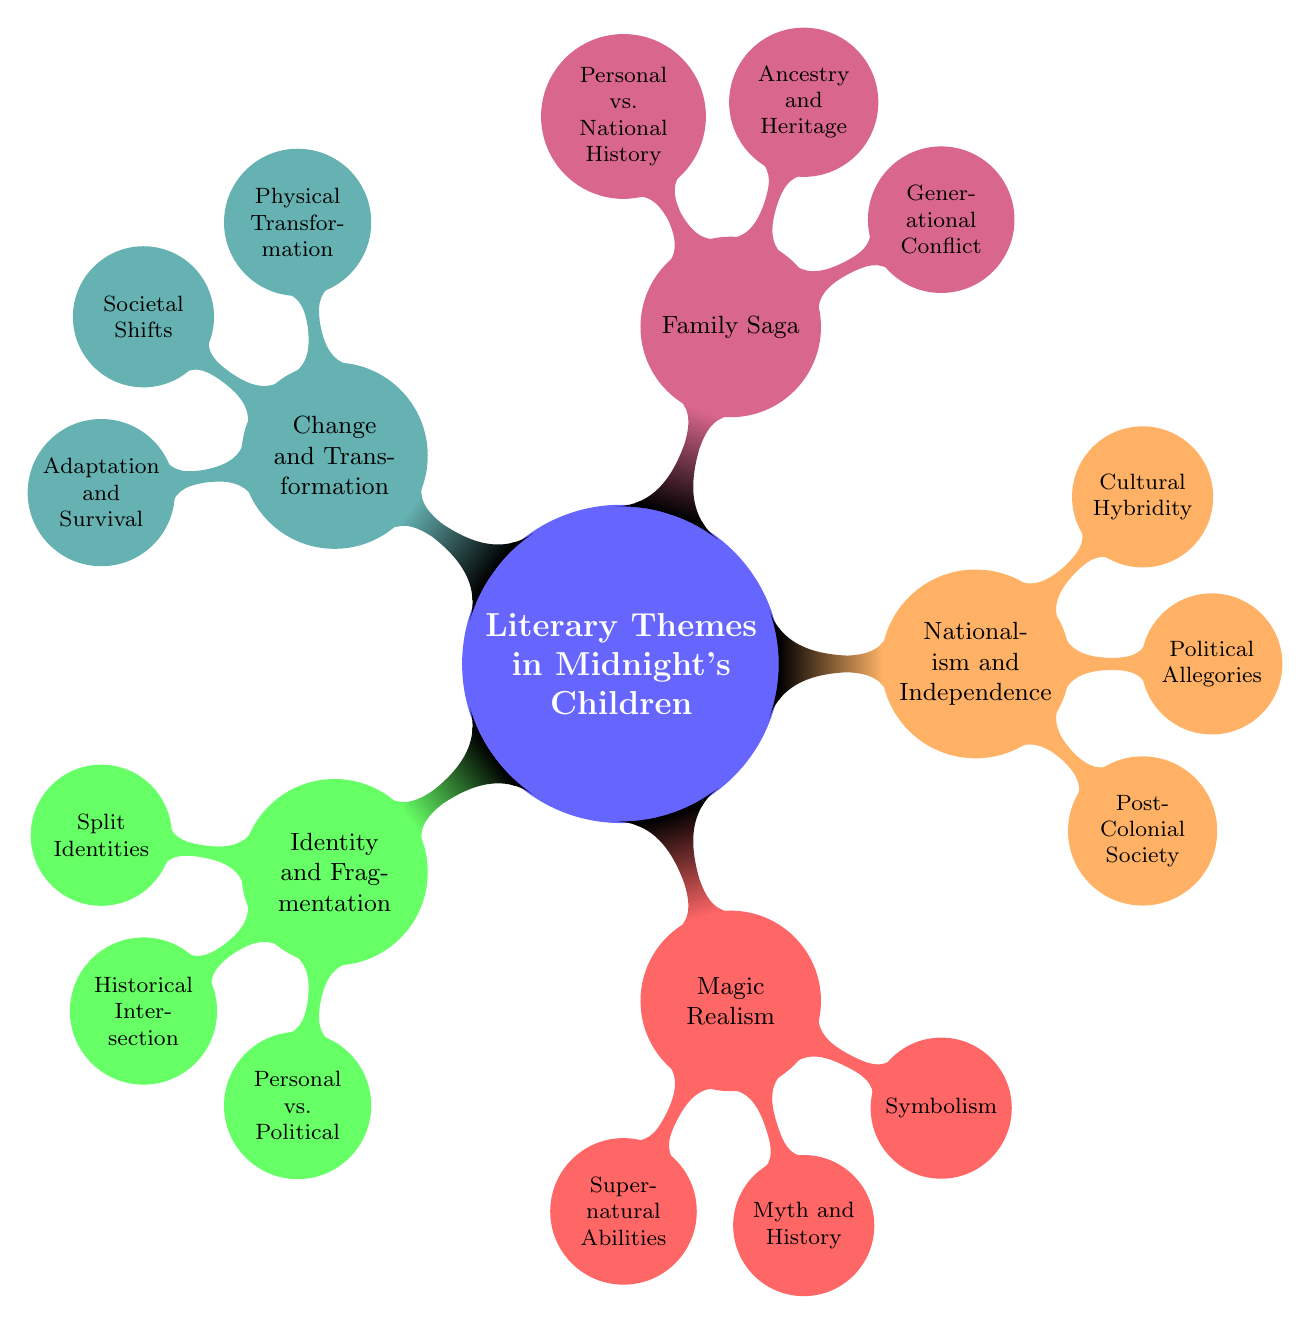What is the main theme of the mind map? The main theme "Literary Themes in Midnight's Children" is at the center of the mind map and encompasses various sub-themes related to the novel.
Answer: Literary Themes in Midnight's Children How many main themes are depicted in the mind map? The mind map shows five main themes branching out from the central node.
Answer: 5 Which theme includes "Supernatural Abilities"? The theme "Magic Realism" contains the sub-theme "Supernatural Abilities" as one of its components.
Answer: Magic Realism What is one example of "Generational Conflict"? "Parvati-the-Witch" is listed as an example under the sub-theme "Generational Conflict" within the "Family Saga" theme.
Answer: Parvati-the-Witch Which theme addresses the concept of "Cultural Hybridity"? The sub-theme "Cultural Hybridity" belongs to "Nationalism and Independence," highlighting diverse ethnic and cultural aspects.
Answer: Nationalism and Independence What connects "Saleem Sinai" and "Shiva"? Both "Saleem Sinai" and "Shiva" are part of the sub-theme "Split Identities" under the "Identity and Fragmentation" theme, representing character duality.
Answer: Split Identities Describe the relationship between "Political Allegories" and "Indira Gandhi". "Political Allegories" includes "Indira Gandhi" as a key figure representing the political dynamics post-independence in India, as shown in the "Nationalism and Independence" theme.
Answer: Political Allegories What theme focuses on "Adaptation and Survival"? The "Change and Transformation" theme encompasses the concept of "Adaptation and Survival," highlighting the characters' resilience through change.
Answer: Change and Transformation Which theme involves "Personal vs. National History"? "Personal vs. National History" is a sub-theme within "Family Saga," indicating the intertwining of individual narratives with national events.
Answer: Family Saga How does "Physical Transformation" relate to "Societal Shifts"? "Physical Transformation" and "Societal Shifts" are both part of the "Change and Transformation" theme, illustrating how personal changes reflect broader societal transformations.
Answer: Change and Transformation 